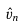Convert formula to latex. <formula><loc_0><loc_0><loc_500><loc_500>\hat { v } _ { n }</formula> 